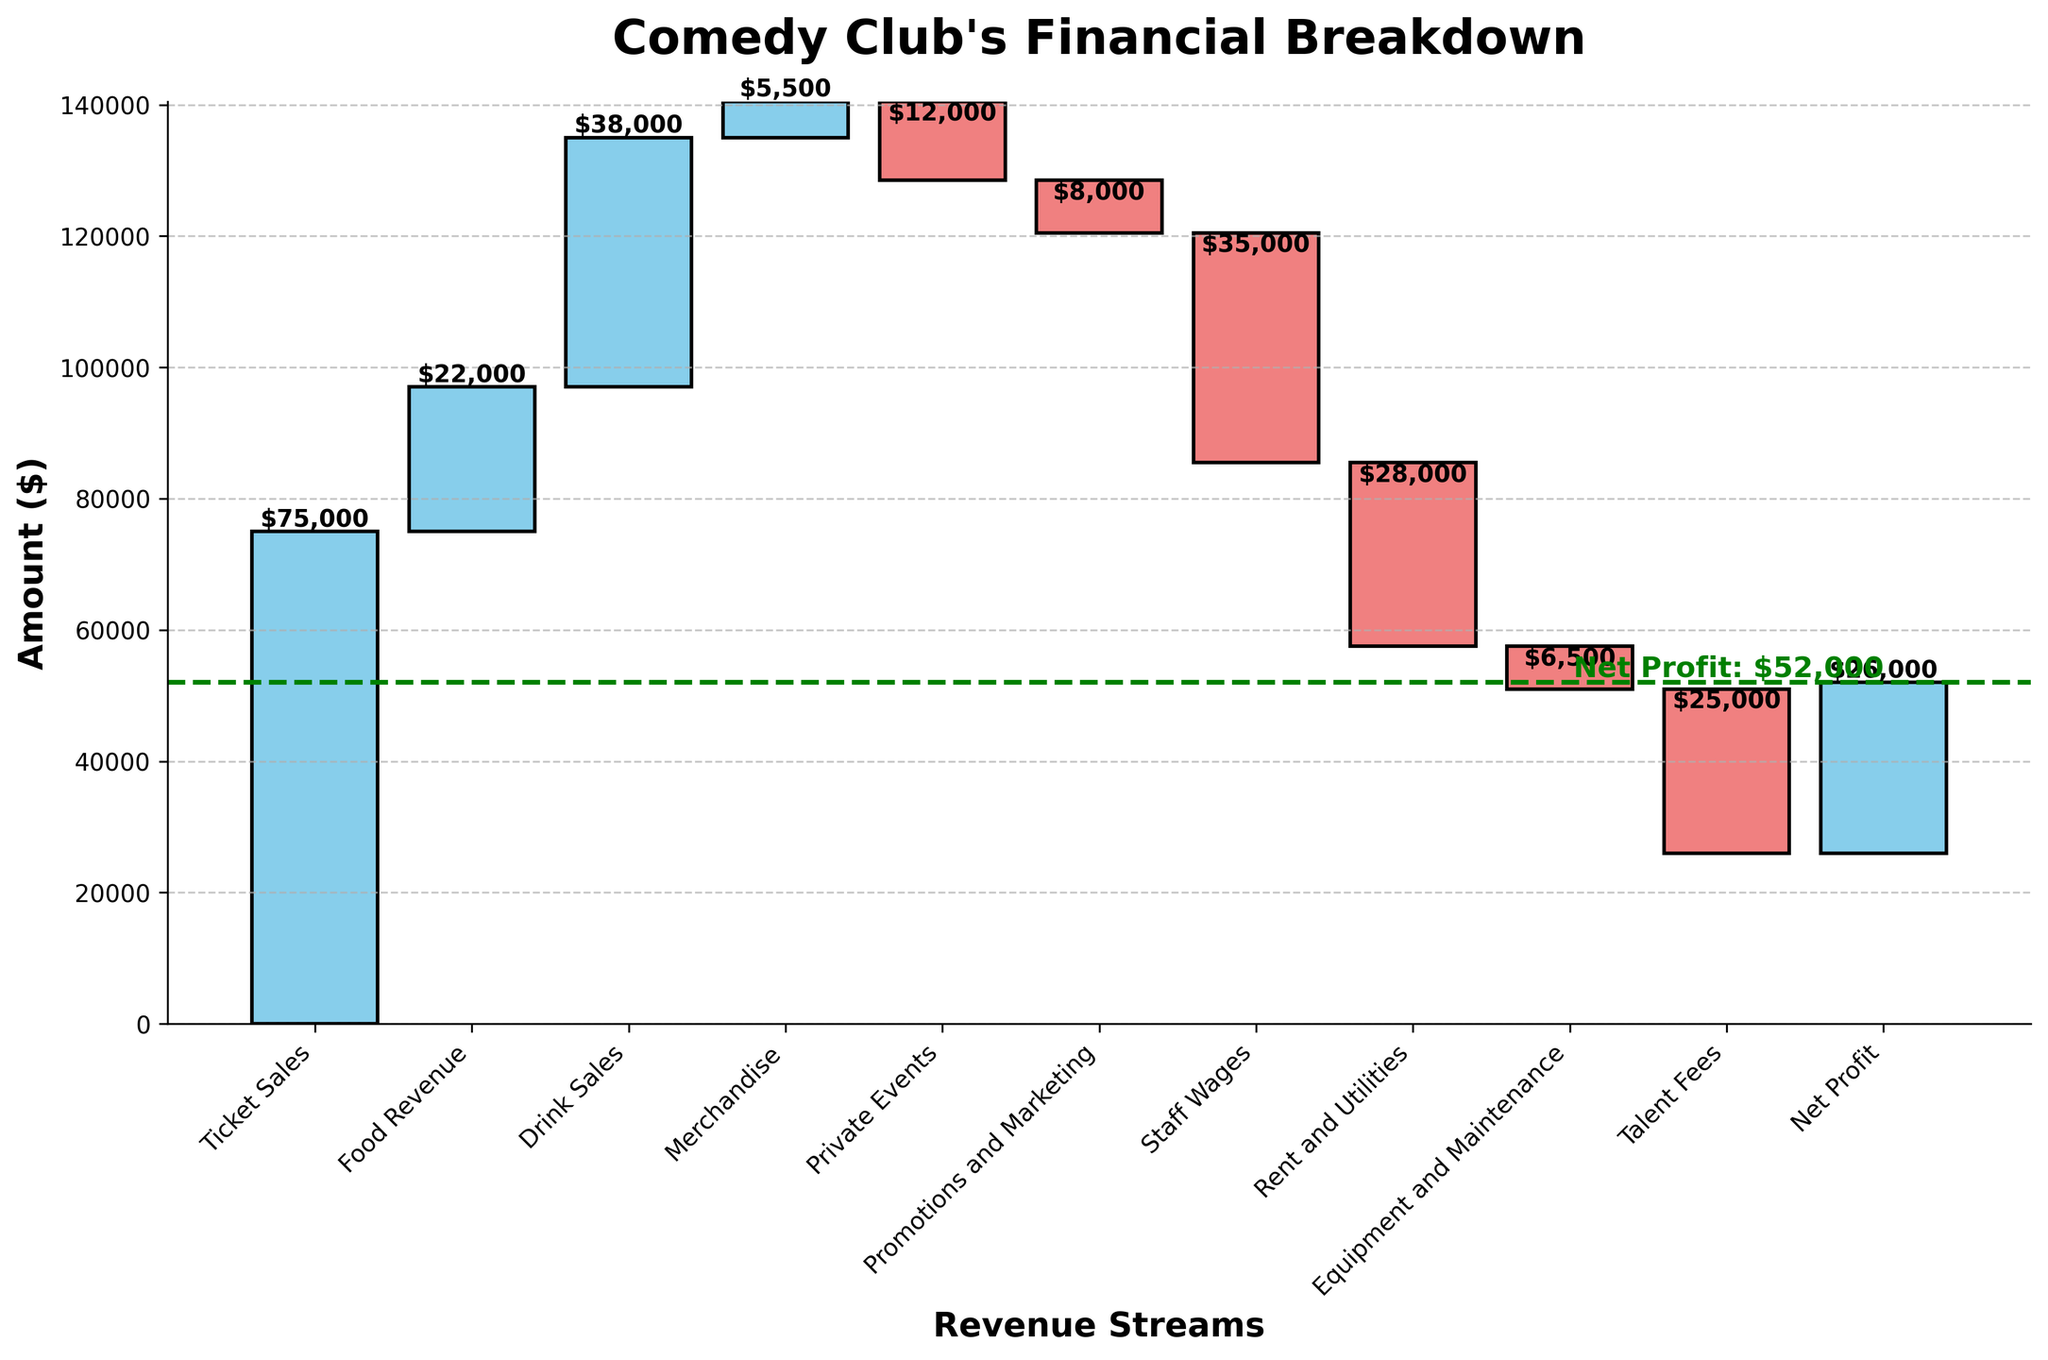Which revenue stream contributes the most to the total revenue? The tallest bar in blue represents the revenue stream with the highest positive value. Here, 'Ticket Sales' with an amount of $75,000 stands out.
Answer: Ticket Sales What is the net profit of the comedy club? The horizontal green dashed line marks the net profit at the end of the chart, and the label indicates $26,000.
Answer: $26,000 How much does the comedy club earn from 'Food Revenue' and 'Drink Sales' combined? Add the values for 'Food Revenue' ($22,000) and 'Drink Sales' ($38,000). $22,000 + $38,000 = $60,000.
Answer: $60,000 Which expense has the highest negative impact on the comedy club's financials? The tallest bar in red indicates the highest expense. 'Staff Wages' with an amount of -$35,000 is the highest.
Answer: Staff Wages What is the total expense for 'Promotions and Marketing' and 'Staff Wages'? Add the negative values for 'Promotions and Marketing' (-$8,000) and 'Staff Wages' (-$35,000). -$8,000 + -$35,000 = -$43,000.
Answer: -$43,000 What's the difference between 'Ticket Sales' and 'Talent Fees'? Subtract 'Talent Fees' amount (-$25,000) from 'Ticket Sales' amount ($75,000). $75,000 - (-$25,000) = $75,000 + $25,000 = $50,000
Answer: $50,000 Which category contributes the least revenue to the comedy club? The shortest blue bar represents the lowest positive amount. Here, 'Merchandise,' with an amount of $5,500, is the least.
Answer: Merchandise What's the cumulative amount before considering 'Net Profit'? The last bar before 'Net Profit' represents the cumulative sum of all prior values. From the green line indicating 'Net Profit,' the value is the net profit without considering 'Net Profit' itself.
Answer: $0 (cumulative ends at net profit point) Between 'Rent and Utilities' and 'Equipment and Maintenance', which one costs more? Comparing the heights of the red bars for these two categories, 'Rent and Utilities' (-$28,000) is greater than 'Equipment and Maintenance' (-$6,500).
Answer: Rent and Utilities What's the recovery amount from 'Private Events' after considering 'Promotions and Marketing'? Subtract 'Promotions and Marketing' amount (-$8,000) from 'Private Events' amount (-$12,000). -$12,000 - (-$8,000) = -$12,000 + $8,000 = -$4,000.
Answer: -$4,000 